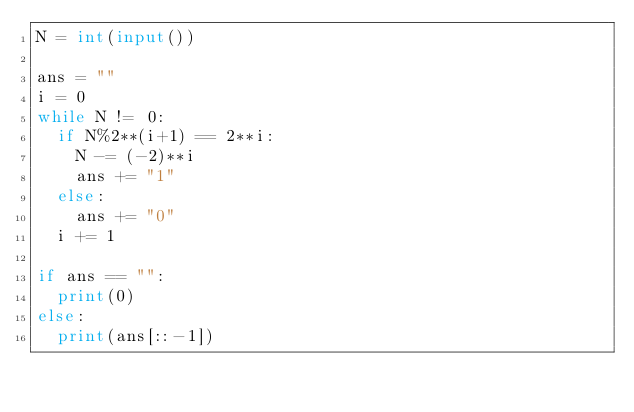Convert code to text. <code><loc_0><loc_0><loc_500><loc_500><_Python_>N = int(input())

ans = ""
i = 0
while N != 0:
  if N%2**(i+1) == 2**i:
    N -= (-2)**i
    ans += "1"
  else:
    ans += "0"
  i += 1

if ans == "":
  print(0)
else:
  print(ans[::-1])</code> 